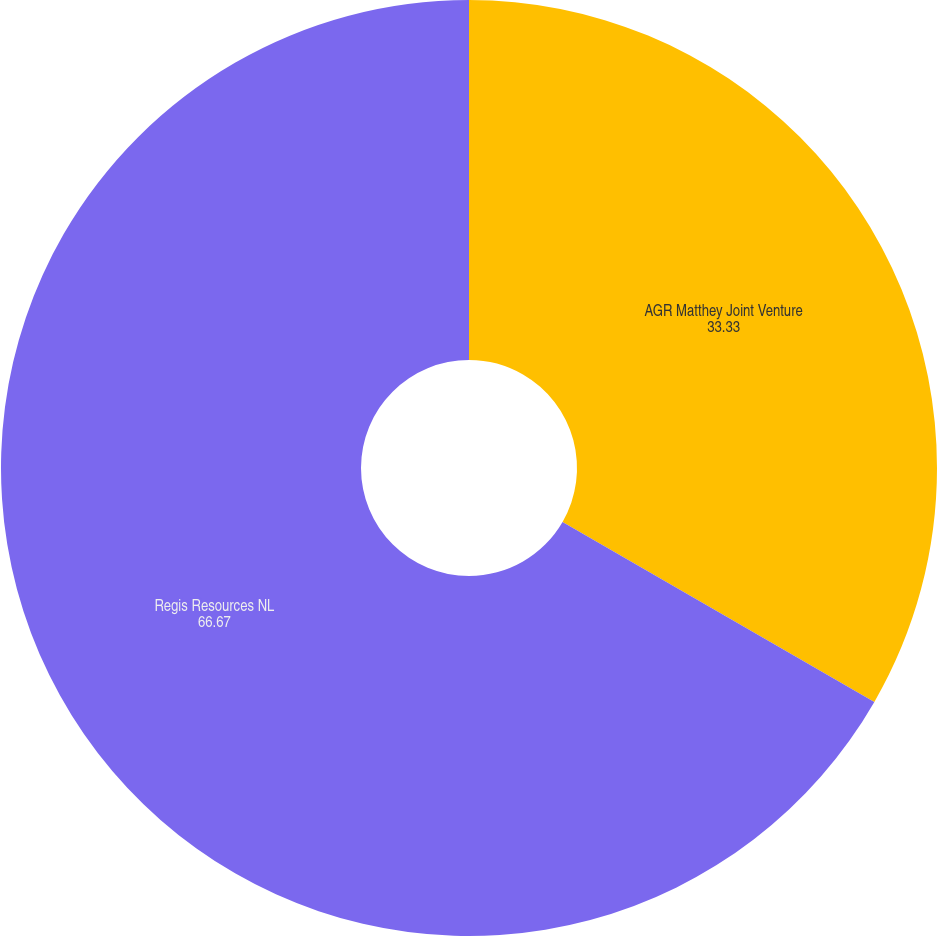Convert chart. <chart><loc_0><loc_0><loc_500><loc_500><pie_chart><fcel>AGR Matthey Joint Venture<fcel>Regis Resources NL<nl><fcel>33.33%<fcel>66.67%<nl></chart> 